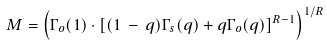Convert formula to latex. <formula><loc_0><loc_0><loc_500><loc_500>M = \left ( \Gamma _ { o } ( 1 ) \cdot \left [ ( 1 \, - \, q ) \Gamma _ { s } ( q ) + q \Gamma _ { o } ( q ) \right ] ^ { R - 1 } \right ) ^ { 1 / R }</formula> 